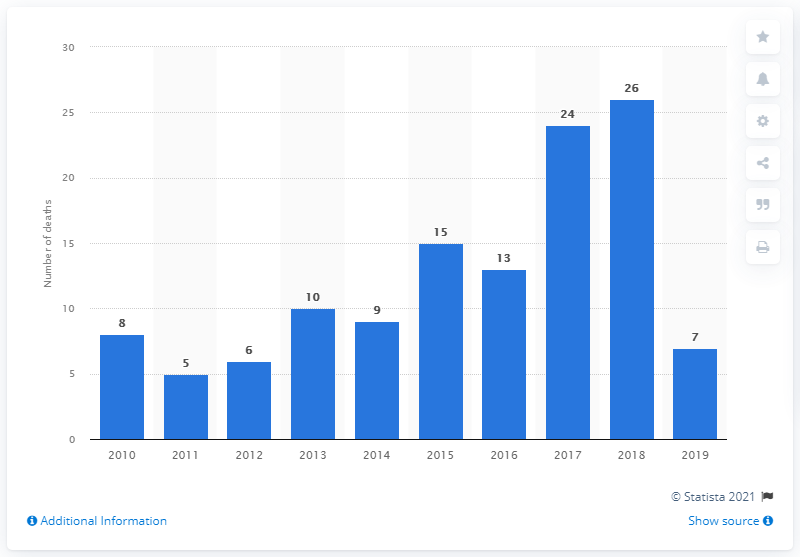Identify some key points in this picture. There were 26 malaria deaths in Haiti in the previous year. At the beginning of the decade, there were 8 deaths due to malaria in Haiti. 